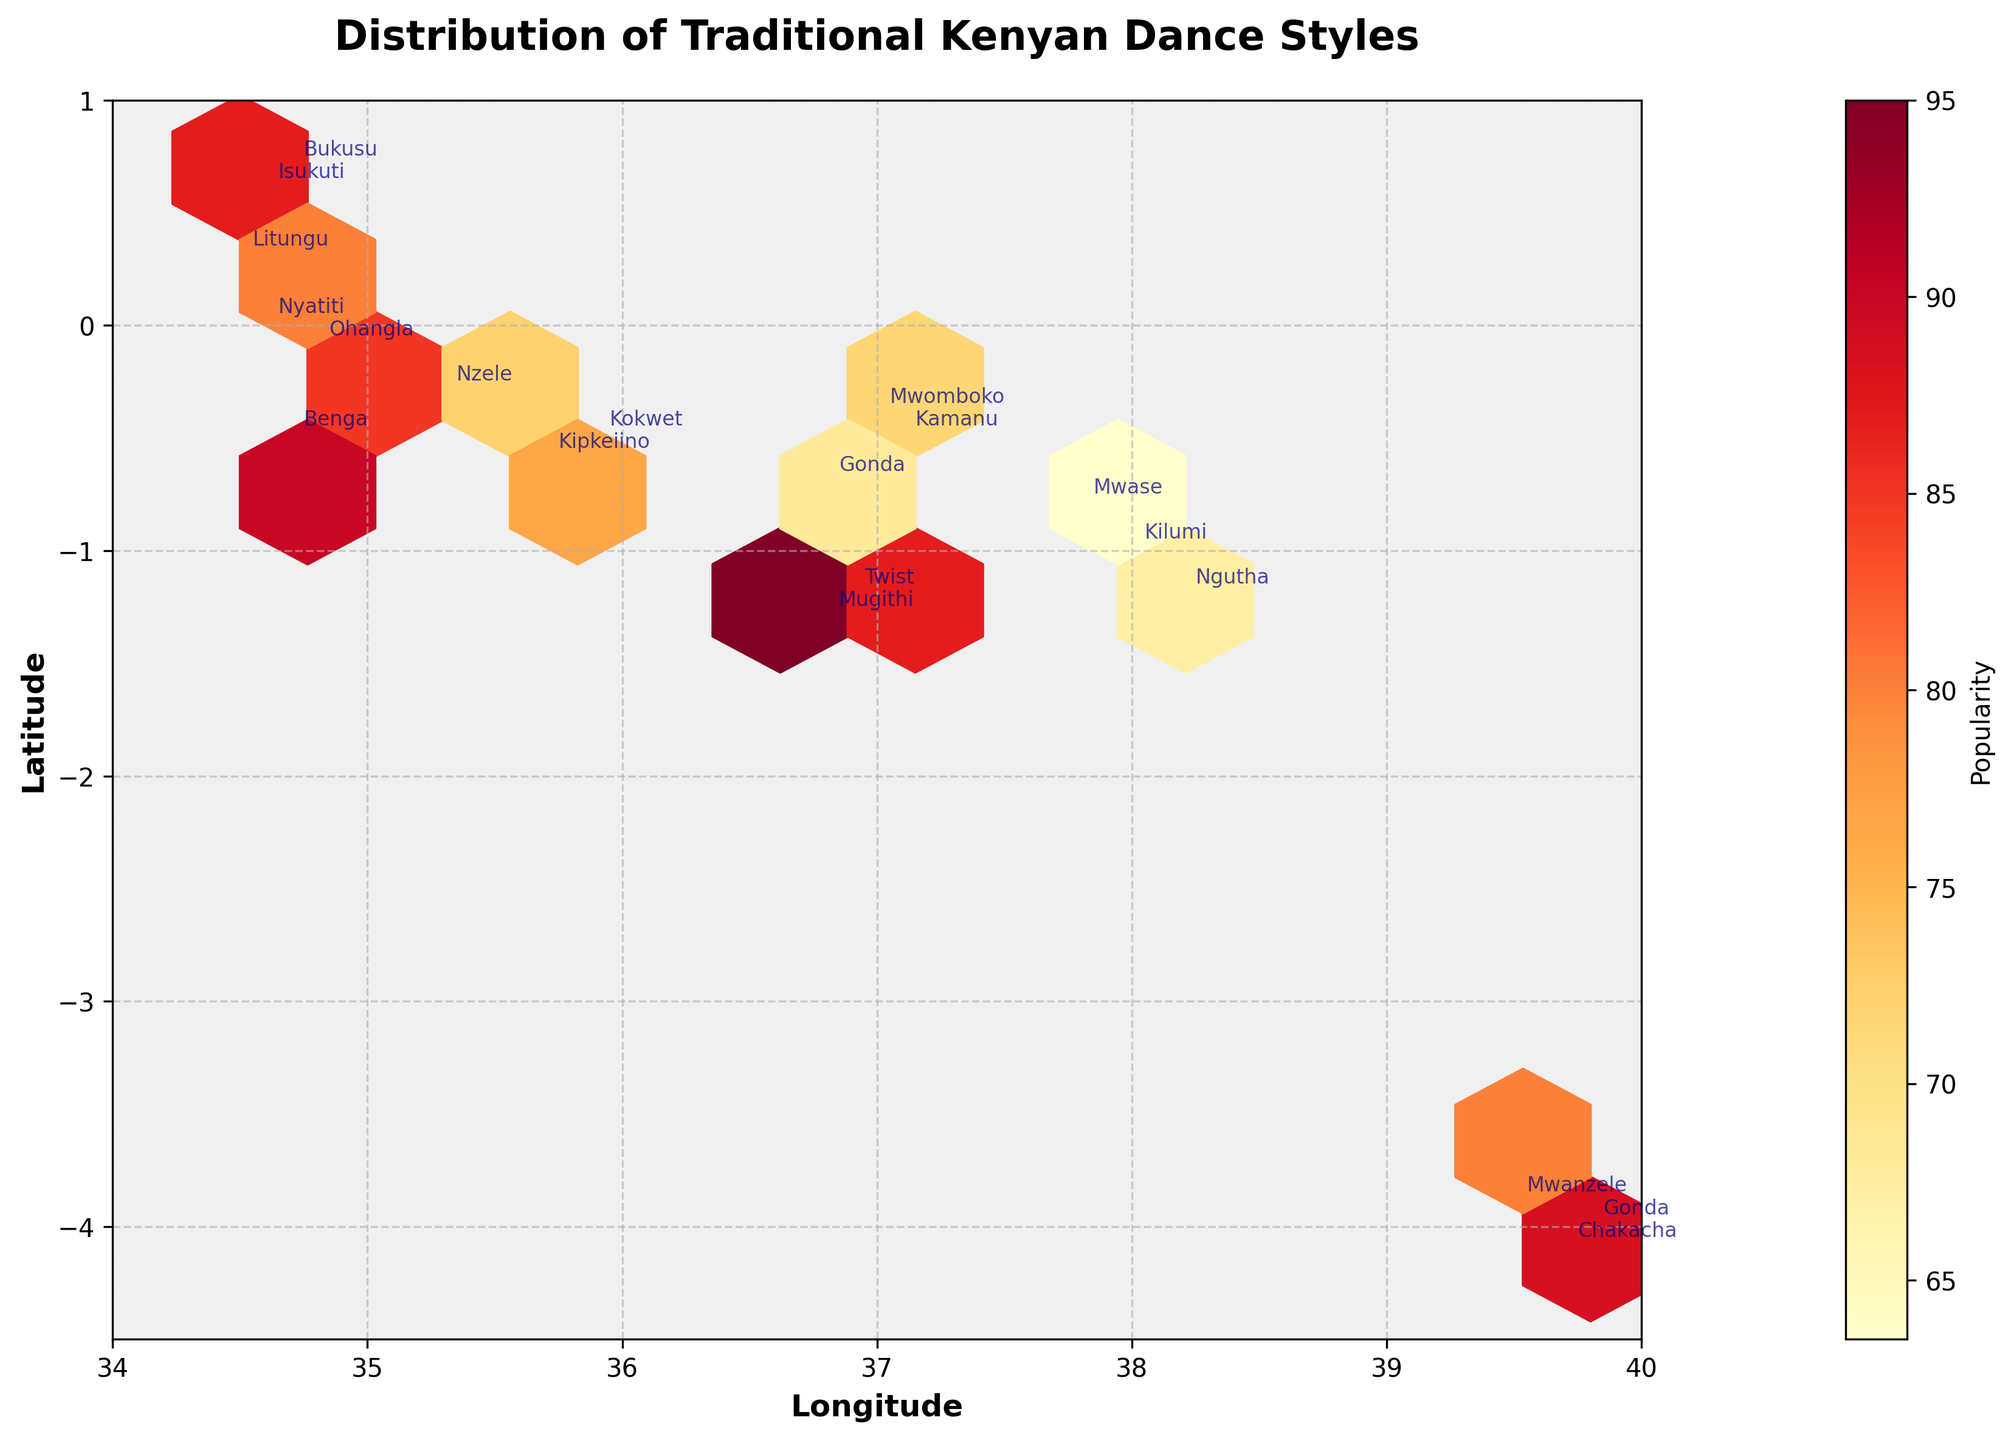How many regions are represented in the plot? The plot displays the traditional dance styles for distinct regions. By counting the unique regions annotated on the plot, we can identify the number represented.
Answer: 8 Which dance style has the highest popularity? By observing the color intensity of each hexagon (where more intense color indicates higher popularity), we can identify the dance style with the highest rating.
Answer: Mugithi What range of popularity values is shown in the color bar? The color bar on the plot visually represents the range of popularity values. By checking the numerical labels on the color bar, we can determine this range.
Answer: 62–95 Which region has the lowest latitude value, and what is its traditional dance style? By locating the region with the point farthest south on the plot (lowest latitude), we can identify the corresponding dance style annotated near that point.
Answer: Coast, Chakacha What is the average longitude of the regions displayed? To find this, sum up the longitudes of all regions and divide by the total number of regions. Sum (35.7 + 39.7 + 34.8 + 37.0 + 34.6 + 38.0 + 36.8 + 39.5 + 35.3 + 34.7 + 36.8 + 34.5 + 37.8 + 36.9 + 35.9 + 39.8 + 34.6 + 37.1 + 38.2) = 683.9. Divide by 19.
Answer: 36.0 Which dance styles are found in the Coast region? By checking the annotated dance styles at the geographical points marked within the longitude and latitude boundaries of the Coast region, we can identify these styles.
Answer: Chakacha, Mwanzele, Gonda Compare the popularities of “Twist” and “Mwase.” Which is higher? Locate the points for “Twist” and “Mwase”, then compare their corresponding color intensities and the popularity values adjacent to their locations.
Answer: Twist Is there any overlap in the popularity ranges of dance styles within the Rift Valley region? Checking the plotted points for the Rift Valley region’s dance styles and comparing the color intensities can determine if there's a similarity or range overlap in their popularity values.
Answer: Yes What is the difference in popularity between the most popular dance style in Nairobi and the least popular in the Eastern region? Identify the popularity values for the dance styles in Nairobi (Mugithi, 95) and the least popular dance in the Eastern region (Mwase, 62). Subtract the lesser value from the greater.
Answer: 33 Which region has the dance style closest to the average latitude of the entire dataset? Calculate the average latitude: Sum (-0.6 + -4.1 + -0.1 + -0.4 + 0.6 + -1.0 + -1.3 + -3.9 + -0.3 + -0.5 + -0.7 + 0.3 + -0.8 + -1.2 + -0.5 + -4.0 + 0.0 + -0.5 + -1.2) = -21.1. Divide by 19. Close to -1.1. Compare this value to the latitudes of all regions
Answer: Eastern, Ngutha 